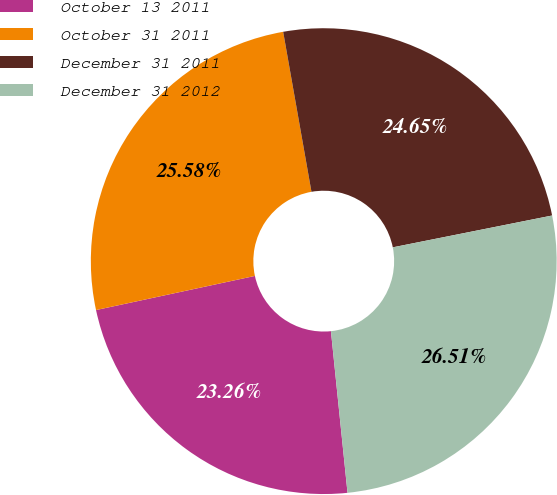<chart> <loc_0><loc_0><loc_500><loc_500><pie_chart><fcel>October 13 2011<fcel>October 31 2011<fcel>December 31 2011<fcel>December 31 2012<nl><fcel>23.26%<fcel>25.58%<fcel>24.65%<fcel>26.51%<nl></chart> 